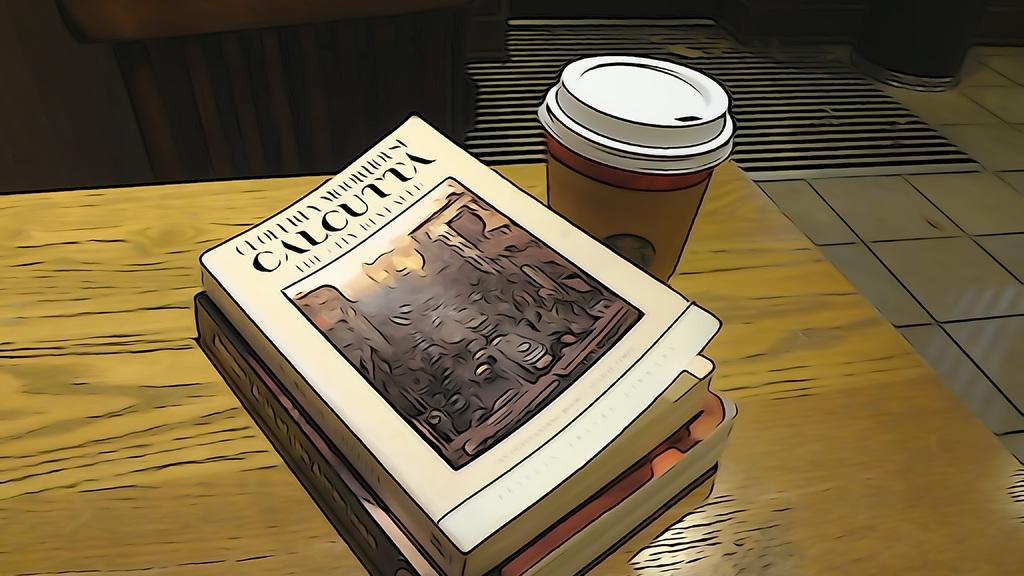Provide a one-sentence caption for the provided image. A cartoon coffee and books, one is entitled Calcutta. 